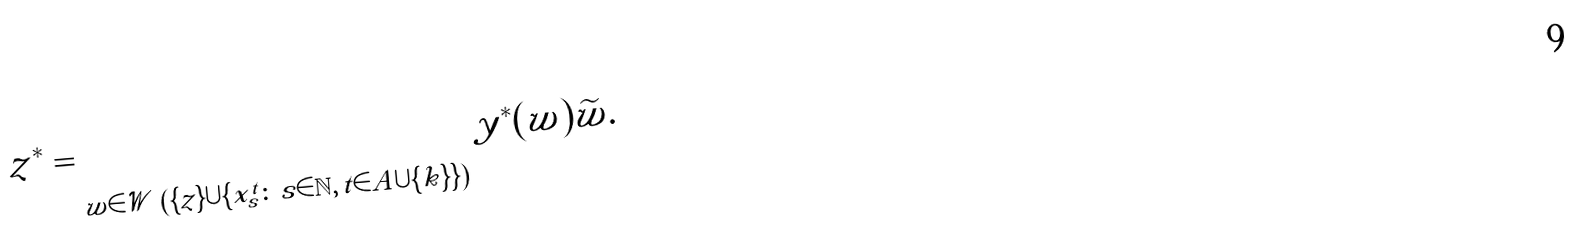Convert formula to latex. <formula><loc_0><loc_0><loc_500><loc_500>z ^ { * } = \sum _ { w \in \mathcal { W } \ \left ( \{ z \} \cup \{ x ^ { t } _ { s } \colon \, s \in \mathbb { N } , \, t \in A \cup \{ k \} \} \right ) } y ^ { * } ( w ) \widetilde { w } .</formula> 